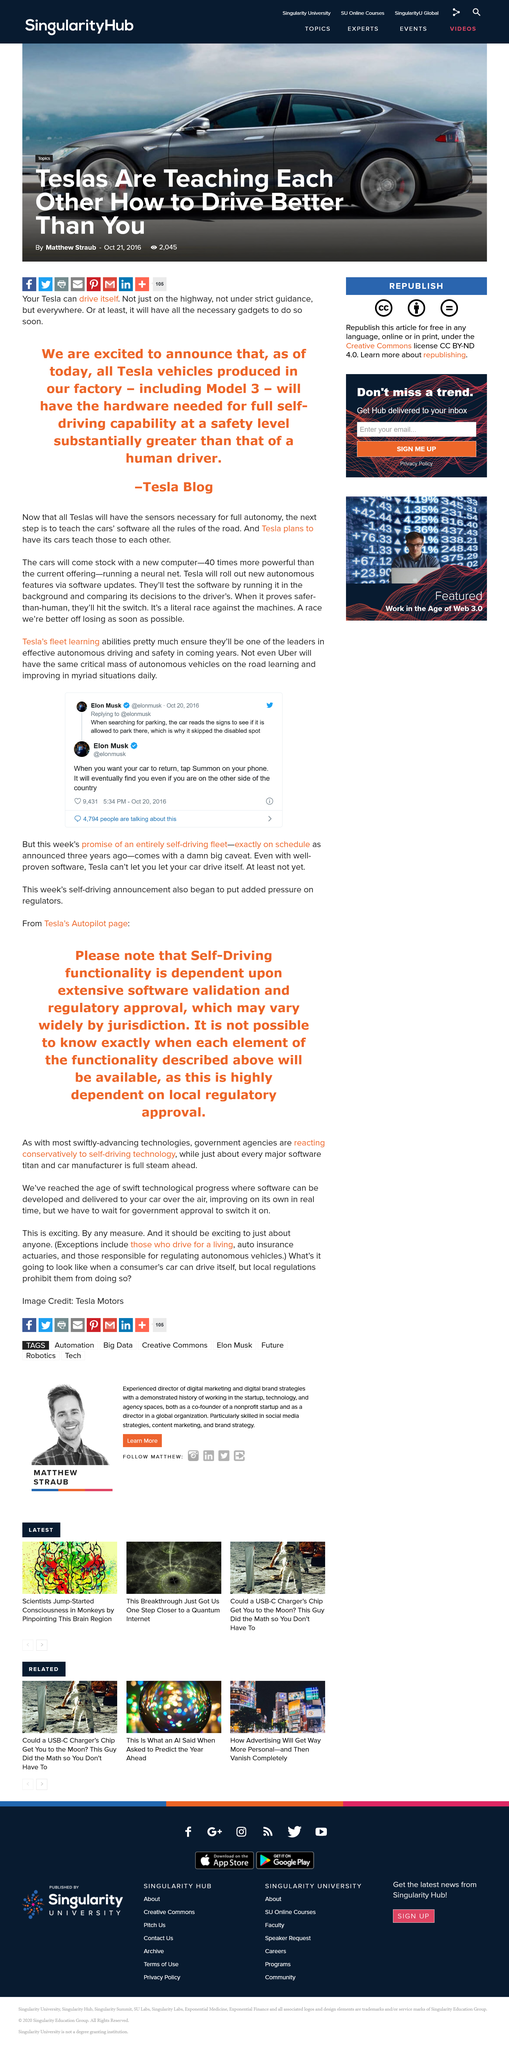Point out several critical features in this image. The promise of an entirely self-driving fleet was announced three years ago. All Teslas will have necessary sensors for full autonomy. According to Elon Musk's tweets, two things are possible with this car: it can read signs while searching for parking, and it can find the driver, even if they are on the other side of the country. 